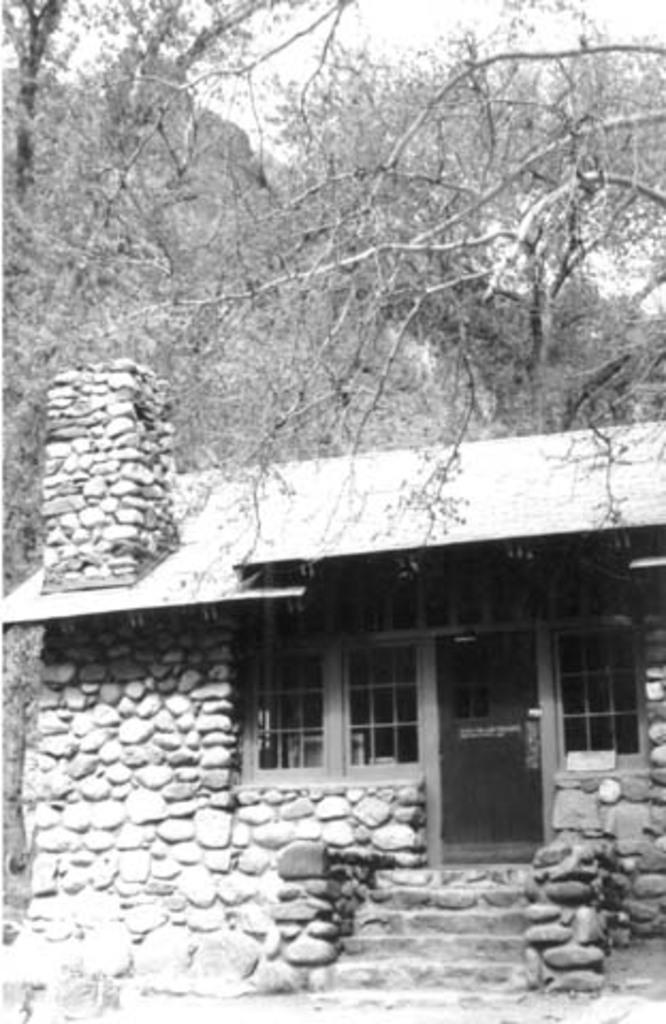What type of house is in the picture? There is a stone house in the picture. What can be seen in the background of the picture? Trees and the sky are visible in the picture. Can you see any fangs in the picture? There are no fangs present in the image. 